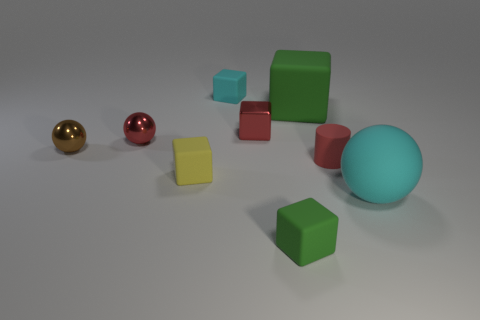How many green rubber cubes have the same size as the cyan cube?
Provide a succinct answer. 1. Are the brown ball that is on the left side of the big green rubber cube and the ball that is behind the brown sphere made of the same material?
Provide a succinct answer. Yes. There is a red thing to the left of the tiny thing behind the big green block; what is it made of?
Offer a very short reply. Metal. There is a sphere that is in front of the small yellow rubber block; what is its material?
Your answer should be compact. Rubber. How many tiny metal things are the same shape as the big cyan object?
Give a very brief answer. 2. Is the color of the big matte sphere the same as the small rubber cylinder?
Make the answer very short. No. There is a tiny red block in front of the matte block that is behind the green matte thing behind the small rubber cylinder; what is it made of?
Your answer should be very brief. Metal. Are there any cyan things behind the yellow matte object?
Your response must be concise. Yes. What shape is the brown thing that is the same size as the red cube?
Ensure brevity in your answer.  Sphere. Does the large cube have the same material as the red sphere?
Provide a succinct answer. No. 